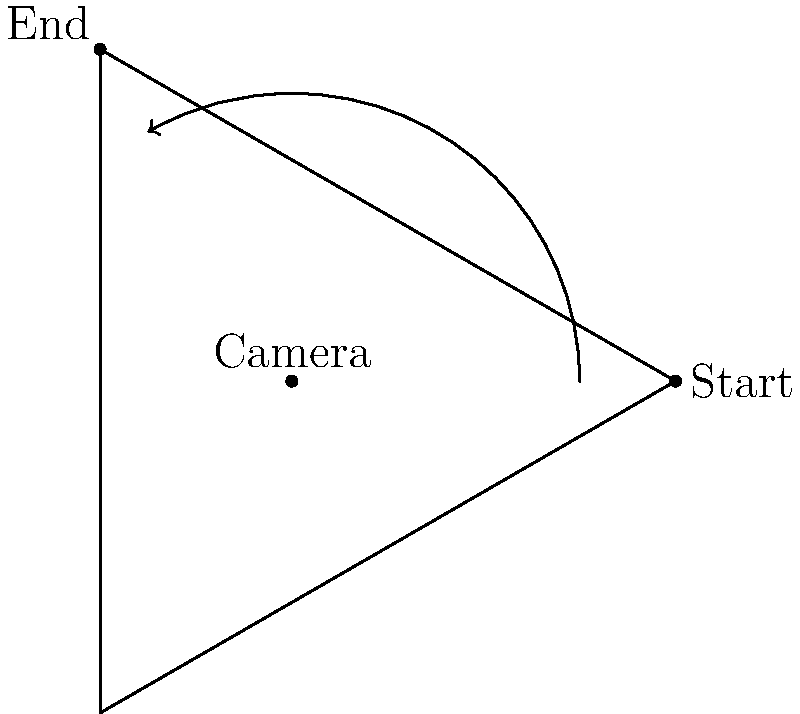In a basic panning shot, the camera rotates horizontally from point A to point B. What is the approximate angle of this panning movement? To determine the angle of the panning movement, we need to follow these steps:

1. Recognize that the camera is at the center of the rotation (point O).
2. Identify the starting point (A) and ending point (B) of the pan.
3. Observe that the angle formed by OA and OB represents the panning angle.
4. In this diagram, we can see that the angle forms one-third of a complete circle.
5. Recall that a complete circle has 360 degrees.
6. Calculate one-third of 360 degrees: $360° ÷ 3 = 120°$

Therefore, the angle of the panning movement from point A to point B is approximately 120 degrees.
Answer: 120 degrees 